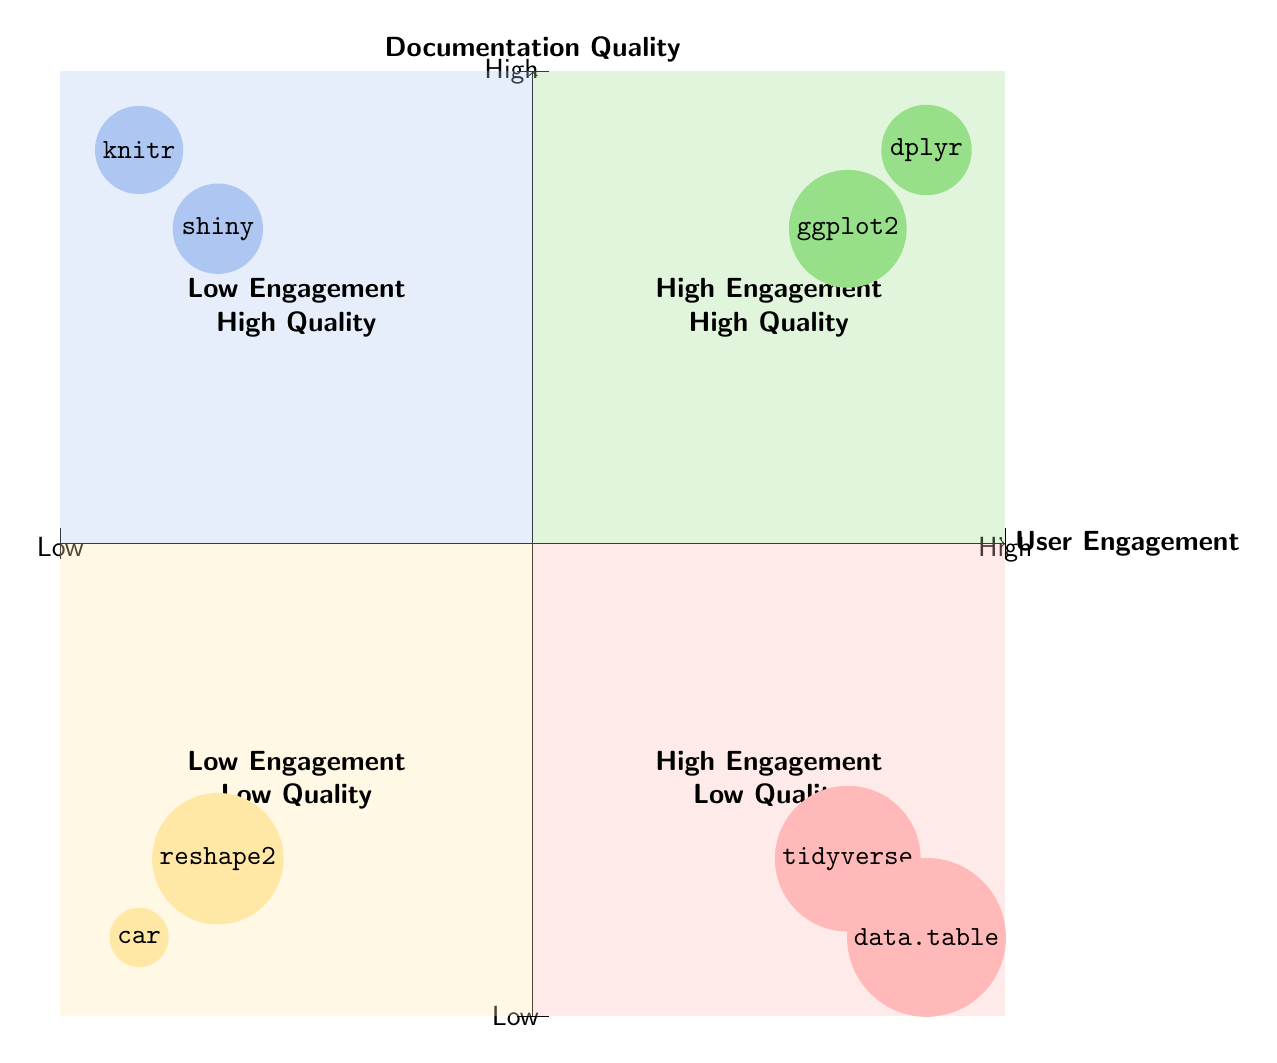What are the packages in the 'High User Engagement - High Documentation Quality' quadrant? This quadrant contains the packages that have both high user engagement and high documentation quality. The diagram shows 'ggplot2' and 'dplyr' in this quadrant.
Answer: ggplot2, dplyr How many packages are located in the 'Low User Engagement - Low Documentation Quality' quadrant? This quadrant represents packages with low user engagement and low documentation quality. According to the diagram, there are two packages: 'reshape2' and 'car'. Thus, the count is two.
Answer: 2 Which quadrant contains the package 'shiny'? The package 'shiny' is depicted in the quadrant representing low user engagement and high documentation quality. Looking at the diagram, we identify the position of 'shiny'.
Answer: Low User Engagement - High Documentation Quality Is there a package with high user engagement but low documentation quality? In the diagram, the quadrant labeled 'High User Engagement - Low Documentation Quality' indicates that there are indeed packages present with high user engagement but low documentation quality. The packages listed are 'tidyverse' and 'data.table'.
Answer: Yes What is the relationship between 'dplyr' and 'ggplot2'? Both 'dplyr' and 'ggplot2' are in the same quadrant titled 'High User Engagement - High Documentation Quality'. This indicates they share similar characteristics regarding user engagement and documentation quality.
Answer: Same quadrant Which quadrant has the package with the highest documentation quality? The quadrant that has the package with the highest documentation quality is 'High User Engagement - High Documentation Quality'. The packages present in this quadrant are 'ggplot2' and 'dplyr', suggesting they are the highest in terms of documentation quality.
Answer: High User Engagement - High Documentation Quality Which package is associated with low engagement but high documentation quality? The package associated with low engagement but high documentation quality is found in the 'Low User Engagement - High Documentation Quality' quadrant. The packages 'shiny' and 'knitr' are placed here on the diagram.
Answer: shiny, knitr How many packages are in the 'High User Engagement - Low Documentation Quality' quadrant? The 'High User Engagement - Low Documentation Quality' quadrant contains two packages, which are 'tidyverse' and 'data.table'. Therefore, the count of packages in this quadrant is two.
Answer: 2 What can we infer about the documentation quality of 'data.table'? 'data.table' is situated in the quadrant labeled 'High User Engagement - Low Documentation Quality', which indicates that while it has high user engagement, its documentation quality is perceived as low.
Answer: Low Documentation Quality 